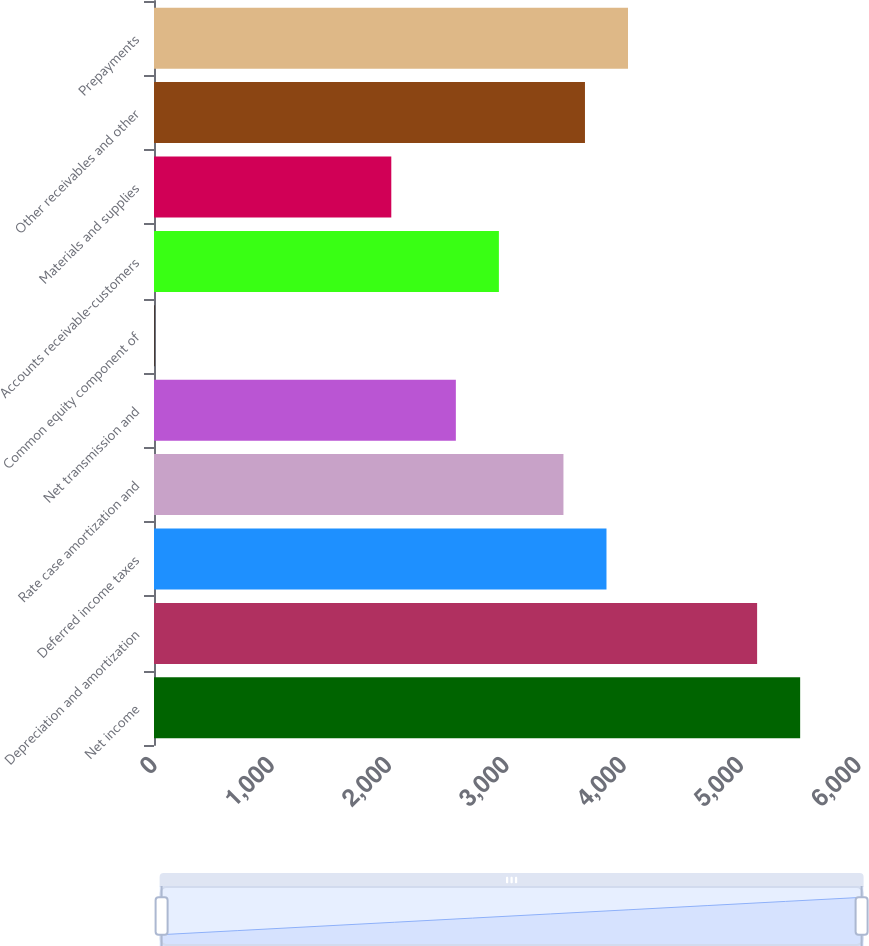Convert chart. <chart><loc_0><loc_0><loc_500><loc_500><bar_chart><fcel>Net income<fcel>Depreciation and amortization<fcel>Deferred income taxes<fcel>Rate case amortization and<fcel>Net transmission and<fcel>Common equity component of<fcel>Accounts receivable-customers<fcel>Materials and supplies<fcel>Other receivables and other<fcel>Prepayments<nl><fcel>5507<fcel>5140.2<fcel>3856.4<fcel>3489.6<fcel>2572.6<fcel>5<fcel>2939.4<fcel>2022.4<fcel>3673<fcel>4039.8<nl></chart> 